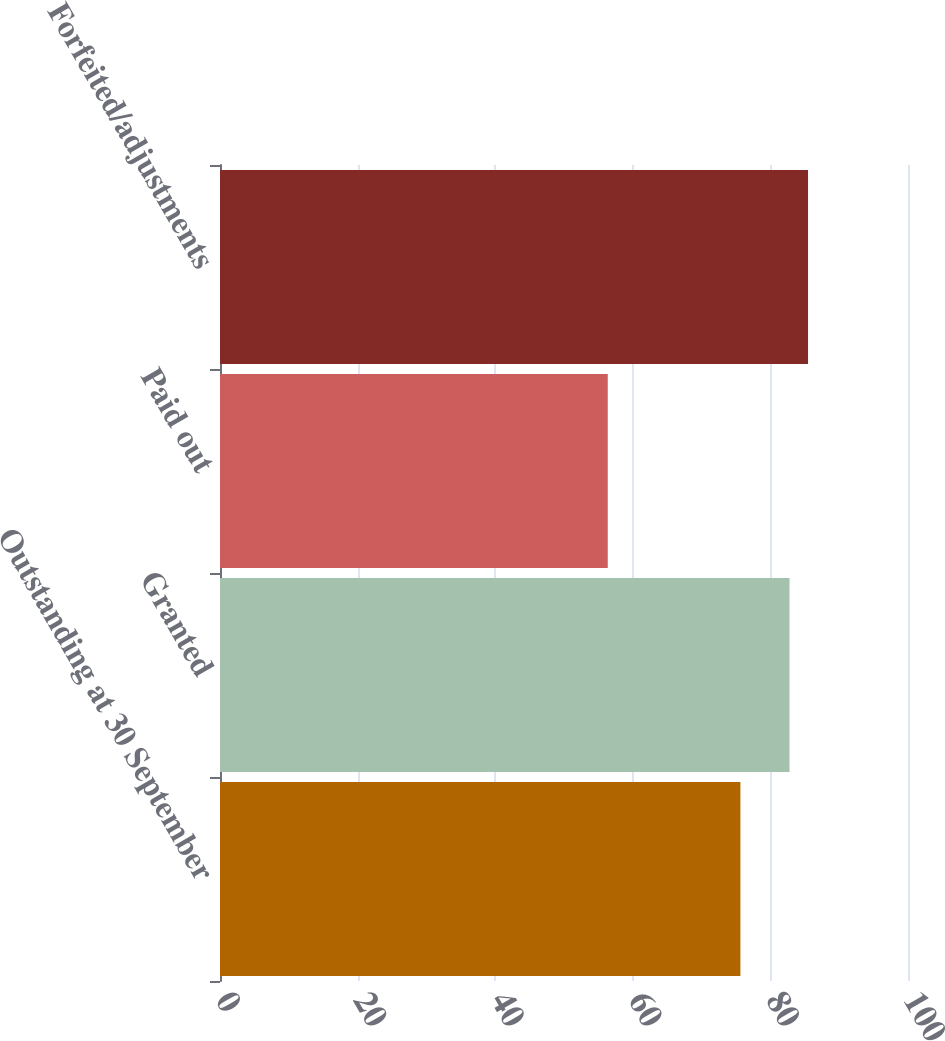Convert chart to OTSL. <chart><loc_0><loc_0><loc_500><loc_500><bar_chart><fcel>Outstanding at 30 September<fcel>Granted<fcel>Paid out<fcel>Forfeited/adjustments<nl><fcel>75.64<fcel>82.78<fcel>56.36<fcel>85.47<nl></chart> 